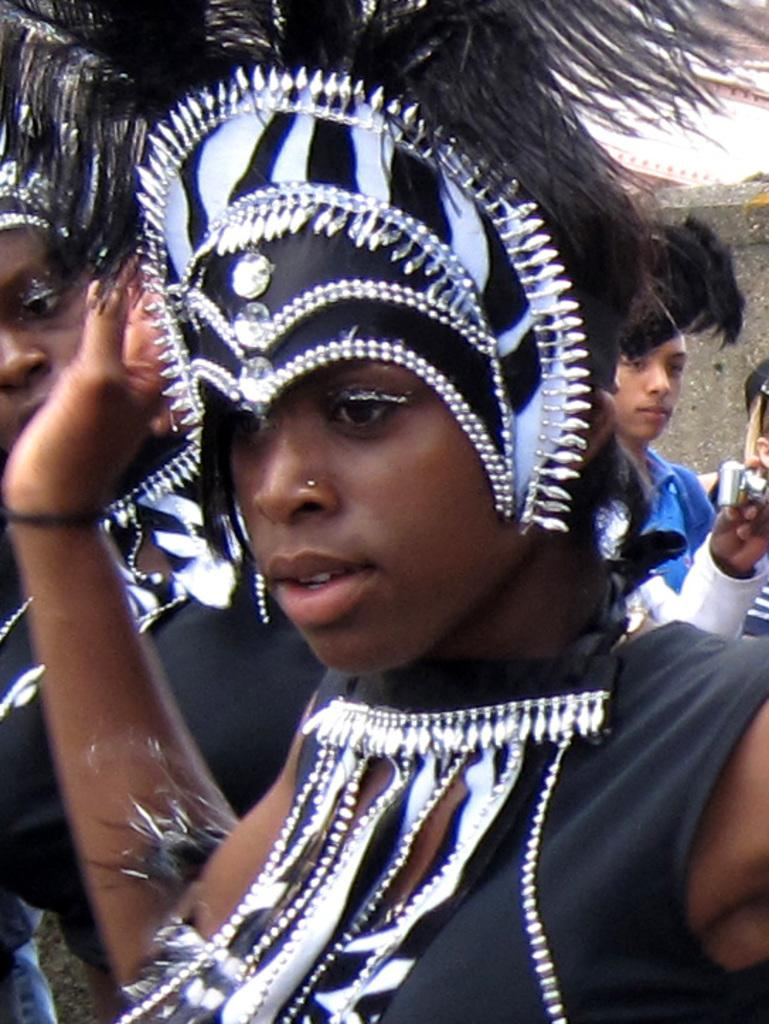What are the two people in the image wearing? The two people in the image are wearing costumes. What object is visible in the image that is commonly used for capturing images? There is a camera visible in the image. What can be seen in the background of the image? There are other people and a wall in the background of the image. What type of leather is being used to make the plate in the image? There is no plate or leather present in the image. 